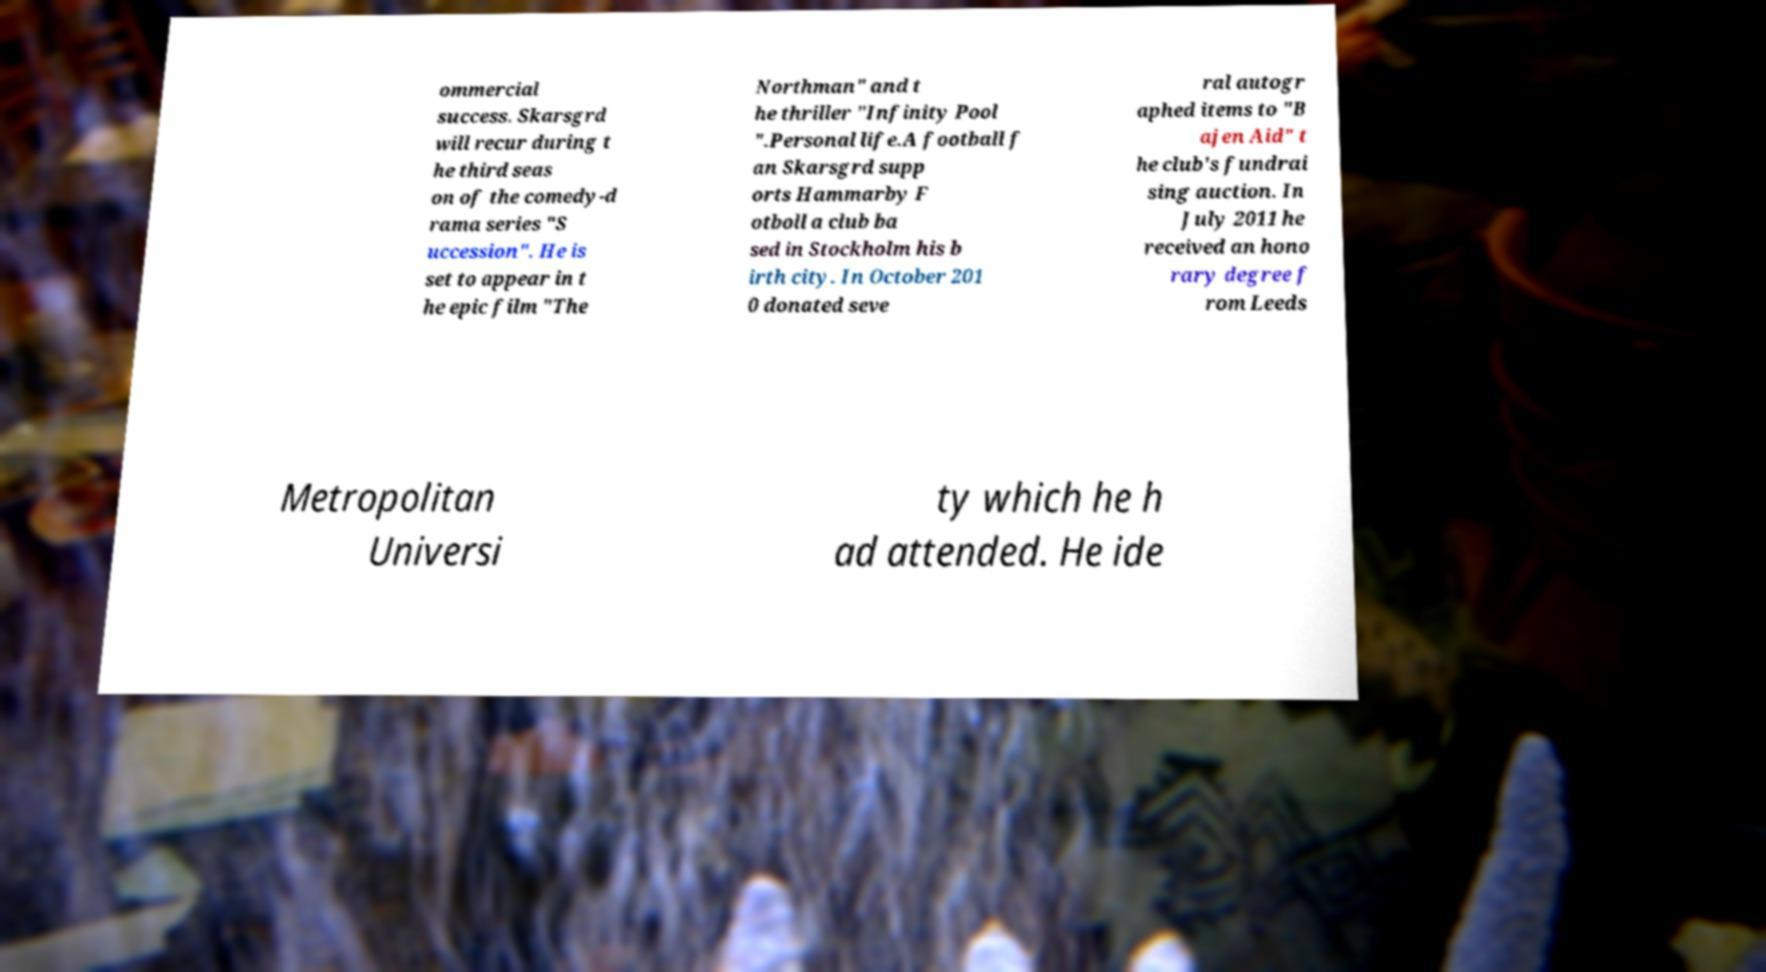Could you assist in decoding the text presented in this image and type it out clearly? ommercial success. Skarsgrd will recur during t he third seas on of the comedy-d rama series "S uccession". He is set to appear in t he epic film "The Northman" and t he thriller "Infinity Pool ".Personal life.A football f an Skarsgrd supp orts Hammarby F otboll a club ba sed in Stockholm his b irth city. In October 201 0 donated seve ral autogr aphed items to "B ajen Aid" t he club's fundrai sing auction. In July 2011 he received an hono rary degree f rom Leeds Metropolitan Universi ty which he h ad attended. He ide 